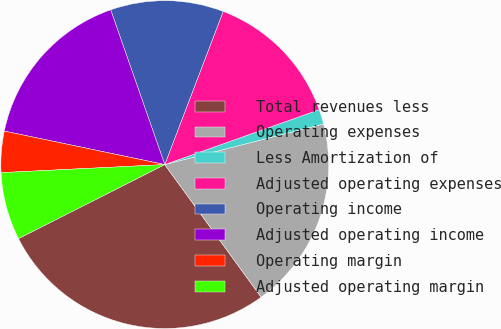Convert chart to OTSL. <chart><loc_0><loc_0><loc_500><loc_500><pie_chart><fcel>Total revenues less<fcel>Operating expenses<fcel>Less Amortization of<fcel>Adjusted operating expenses<fcel>Operating income<fcel>Adjusted operating income<fcel>Operating margin<fcel>Adjusted operating margin<nl><fcel>27.54%<fcel>18.98%<fcel>1.45%<fcel>13.76%<fcel>11.15%<fcel>16.37%<fcel>4.06%<fcel>6.67%<nl></chart> 